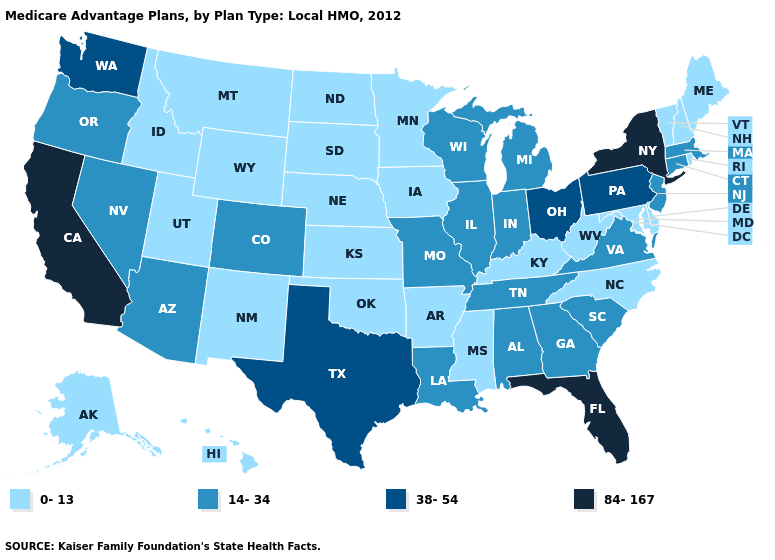What is the value of Kentucky?
Give a very brief answer. 0-13. Name the states that have a value in the range 14-34?
Short answer required. Alabama, Arizona, Colorado, Connecticut, Georgia, Illinois, Indiana, Louisiana, Massachusetts, Michigan, Missouri, New Jersey, Nevada, Oregon, South Carolina, Tennessee, Virginia, Wisconsin. What is the highest value in states that border New York?
Be succinct. 38-54. What is the lowest value in the South?
Keep it brief. 0-13. Among the states that border Rhode Island , which have the lowest value?
Concise answer only. Connecticut, Massachusetts. Among the states that border Alabama , which have the highest value?
Concise answer only. Florida. What is the value of Illinois?
Quick response, please. 14-34. What is the lowest value in the Northeast?
Write a very short answer. 0-13. How many symbols are there in the legend?
Concise answer only. 4. Name the states that have a value in the range 0-13?
Give a very brief answer. Alaska, Arkansas, Delaware, Hawaii, Iowa, Idaho, Kansas, Kentucky, Maryland, Maine, Minnesota, Mississippi, Montana, North Carolina, North Dakota, Nebraska, New Hampshire, New Mexico, Oklahoma, Rhode Island, South Dakota, Utah, Vermont, West Virginia, Wyoming. Among the states that border Texas , does Louisiana have the highest value?
Quick response, please. Yes. Which states hav the highest value in the Northeast?
Answer briefly. New York. What is the value of Vermont?
Concise answer only. 0-13. Name the states that have a value in the range 84-167?
Short answer required. California, Florida, New York. Among the states that border Tennessee , does Alabama have the highest value?
Short answer required. Yes. 